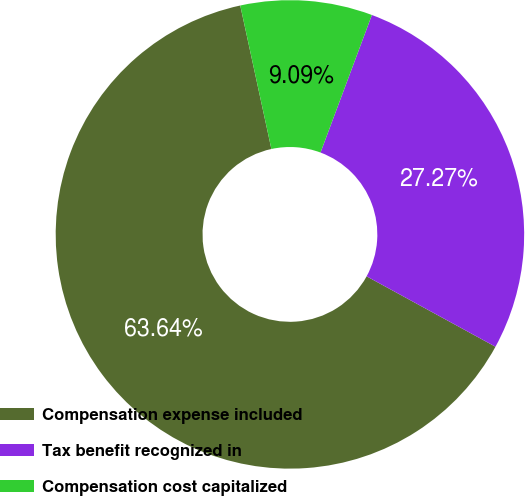Convert chart to OTSL. <chart><loc_0><loc_0><loc_500><loc_500><pie_chart><fcel>Compensation expense included<fcel>Tax benefit recognized in<fcel>Compensation cost capitalized<nl><fcel>63.64%<fcel>27.27%<fcel>9.09%<nl></chart> 